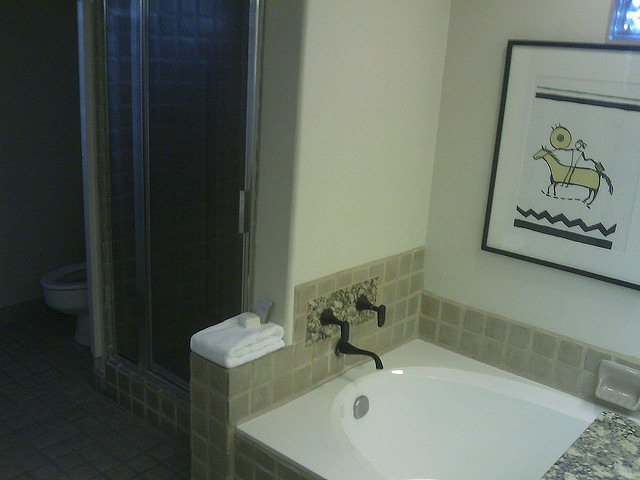<image>Is the tile the same in the shower and bath? It is ambiguous whether the tile is the same in the shower and bath. What is the item draped over the tub? I am not sure what the item draped over the tub is. It could be a curtain, a towel, a painting, or there might not be anything. Is the tile the same in the shower and bath? I don't know if the tile is the same in the shower and bath. It can be both yes or no. What is the item draped over the tub? I am not sure what the item draped over the tub is. It can be seen as a towel or nothing. 